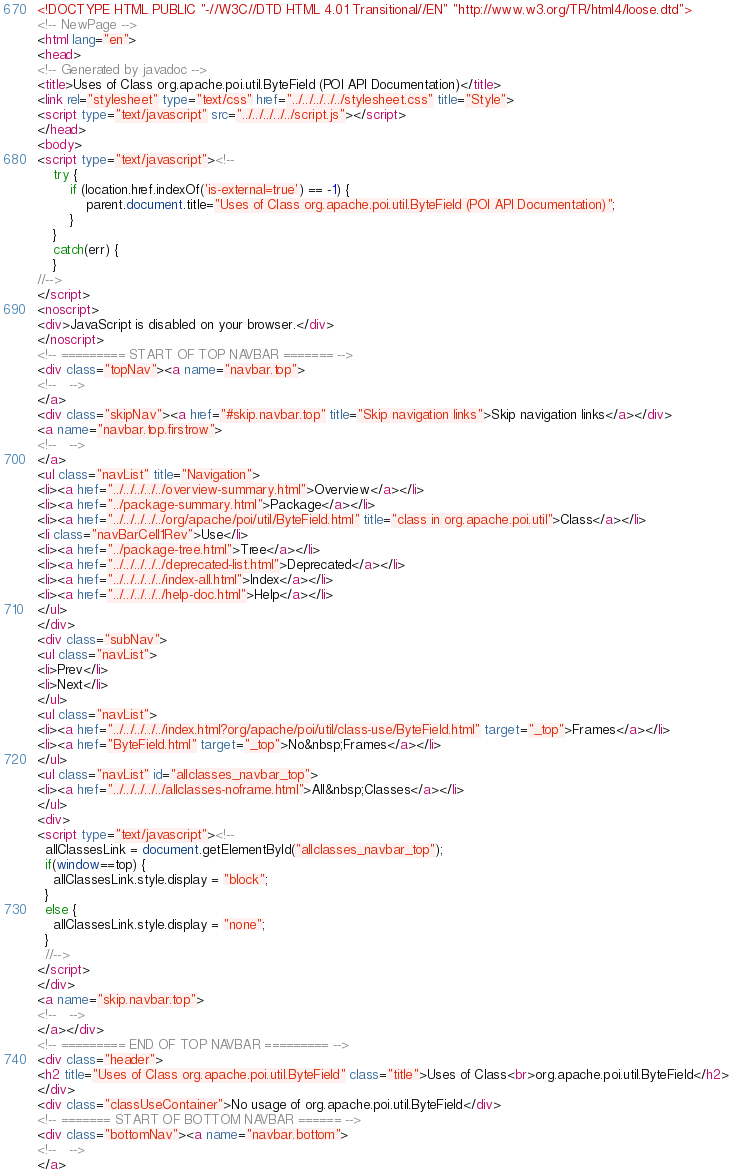Convert code to text. <code><loc_0><loc_0><loc_500><loc_500><_HTML_><!DOCTYPE HTML PUBLIC "-//W3C//DTD HTML 4.01 Transitional//EN" "http://www.w3.org/TR/html4/loose.dtd">
<!-- NewPage -->
<html lang="en">
<head>
<!-- Generated by javadoc -->
<title>Uses of Class org.apache.poi.util.ByteField (POI API Documentation)</title>
<link rel="stylesheet" type="text/css" href="../../../../../stylesheet.css" title="Style">
<script type="text/javascript" src="../../../../../script.js"></script>
</head>
<body>
<script type="text/javascript"><!--
    try {
        if (location.href.indexOf('is-external=true') == -1) {
            parent.document.title="Uses of Class org.apache.poi.util.ByteField (POI API Documentation)";
        }
    }
    catch(err) {
    }
//-->
</script>
<noscript>
<div>JavaScript is disabled on your browser.</div>
</noscript>
<!-- ========= START OF TOP NAVBAR ======= -->
<div class="topNav"><a name="navbar.top">
<!--   -->
</a>
<div class="skipNav"><a href="#skip.navbar.top" title="Skip navigation links">Skip navigation links</a></div>
<a name="navbar.top.firstrow">
<!--   -->
</a>
<ul class="navList" title="Navigation">
<li><a href="../../../../../overview-summary.html">Overview</a></li>
<li><a href="../package-summary.html">Package</a></li>
<li><a href="../../../../../org/apache/poi/util/ByteField.html" title="class in org.apache.poi.util">Class</a></li>
<li class="navBarCell1Rev">Use</li>
<li><a href="../package-tree.html">Tree</a></li>
<li><a href="../../../../../deprecated-list.html">Deprecated</a></li>
<li><a href="../../../../../index-all.html">Index</a></li>
<li><a href="../../../../../help-doc.html">Help</a></li>
</ul>
</div>
<div class="subNav">
<ul class="navList">
<li>Prev</li>
<li>Next</li>
</ul>
<ul class="navList">
<li><a href="../../../../../index.html?org/apache/poi/util/class-use/ByteField.html" target="_top">Frames</a></li>
<li><a href="ByteField.html" target="_top">No&nbsp;Frames</a></li>
</ul>
<ul class="navList" id="allclasses_navbar_top">
<li><a href="../../../../../allclasses-noframe.html">All&nbsp;Classes</a></li>
</ul>
<div>
<script type="text/javascript"><!--
  allClassesLink = document.getElementById("allclasses_navbar_top");
  if(window==top) {
    allClassesLink.style.display = "block";
  }
  else {
    allClassesLink.style.display = "none";
  }
  //-->
</script>
</div>
<a name="skip.navbar.top">
<!--   -->
</a></div>
<!-- ========= END OF TOP NAVBAR ========= -->
<div class="header">
<h2 title="Uses of Class org.apache.poi.util.ByteField" class="title">Uses of Class<br>org.apache.poi.util.ByteField</h2>
</div>
<div class="classUseContainer">No usage of org.apache.poi.util.ByteField</div>
<!-- ======= START OF BOTTOM NAVBAR ====== -->
<div class="bottomNav"><a name="navbar.bottom">
<!--   -->
</a></code> 